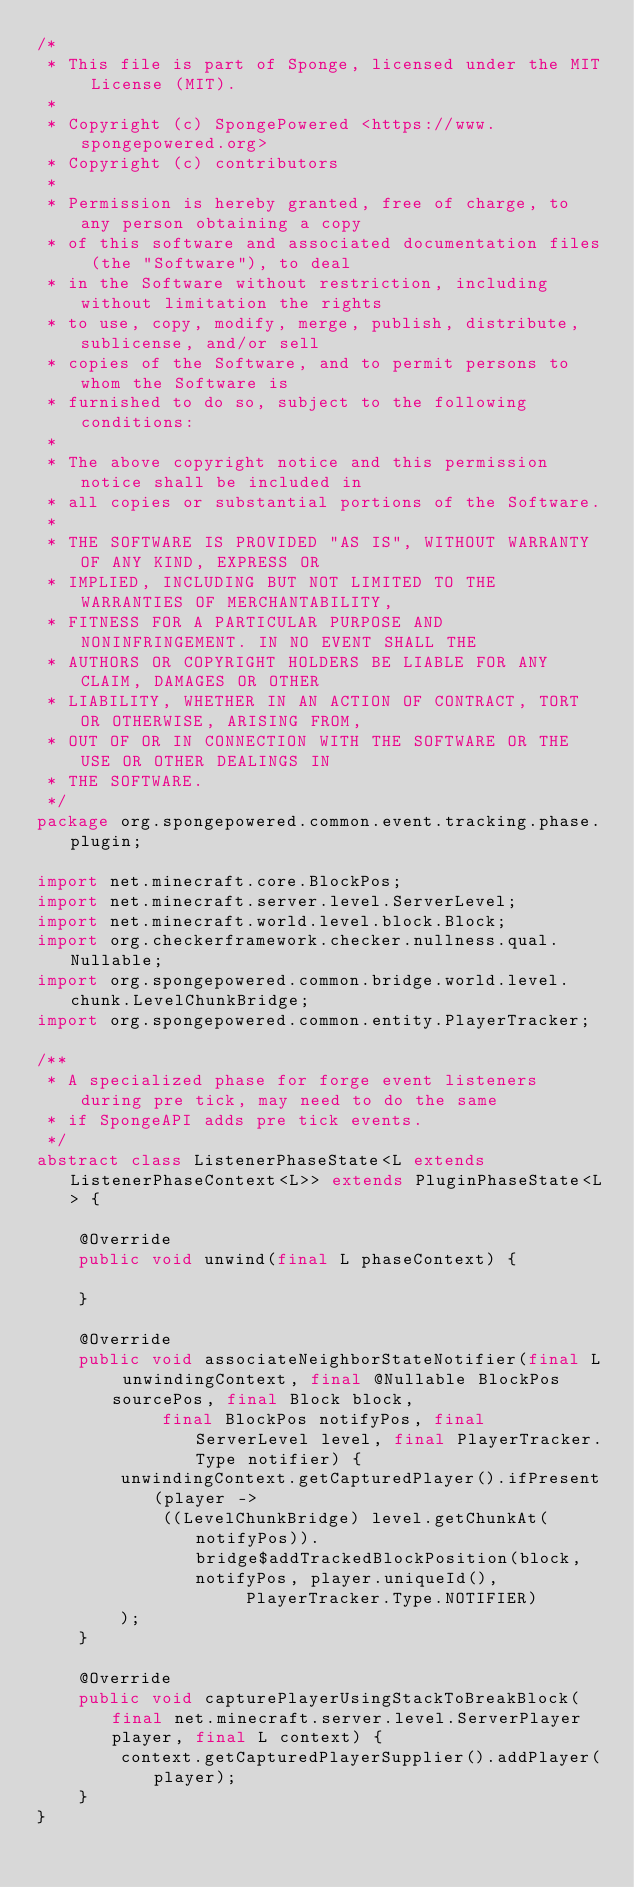Convert code to text. <code><loc_0><loc_0><loc_500><loc_500><_Java_>/*
 * This file is part of Sponge, licensed under the MIT License (MIT).
 *
 * Copyright (c) SpongePowered <https://www.spongepowered.org>
 * Copyright (c) contributors
 *
 * Permission is hereby granted, free of charge, to any person obtaining a copy
 * of this software and associated documentation files (the "Software"), to deal
 * in the Software without restriction, including without limitation the rights
 * to use, copy, modify, merge, publish, distribute, sublicense, and/or sell
 * copies of the Software, and to permit persons to whom the Software is
 * furnished to do so, subject to the following conditions:
 *
 * The above copyright notice and this permission notice shall be included in
 * all copies or substantial portions of the Software.
 *
 * THE SOFTWARE IS PROVIDED "AS IS", WITHOUT WARRANTY OF ANY KIND, EXPRESS OR
 * IMPLIED, INCLUDING BUT NOT LIMITED TO THE WARRANTIES OF MERCHANTABILITY,
 * FITNESS FOR A PARTICULAR PURPOSE AND NONINFRINGEMENT. IN NO EVENT SHALL THE
 * AUTHORS OR COPYRIGHT HOLDERS BE LIABLE FOR ANY CLAIM, DAMAGES OR OTHER
 * LIABILITY, WHETHER IN AN ACTION OF CONTRACT, TORT OR OTHERWISE, ARISING FROM,
 * OUT OF OR IN CONNECTION WITH THE SOFTWARE OR THE USE OR OTHER DEALINGS IN
 * THE SOFTWARE.
 */
package org.spongepowered.common.event.tracking.phase.plugin;

import net.minecraft.core.BlockPos;
import net.minecraft.server.level.ServerLevel;
import net.minecraft.world.level.block.Block;
import org.checkerframework.checker.nullness.qual.Nullable;
import org.spongepowered.common.bridge.world.level.chunk.LevelChunkBridge;
import org.spongepowered.common.entity.PlayerTracker;

/**
 * A specialized phase for forge event listeners during pre tick, may need to do the same
 * if SpongeAPI adds pre tick events.
 */
abstract class ListenerPhaseState<L extends ListenerPhaseContext<L>> extends PluginPhaseState<L> {

    @Override
    public void unwind(final L phaseContext) {

    }

    @Override
    public void associateNeighborStateNotifier(final L unwindingContext, final @Nullable BlockPos sourcePos, final Block block,
            final BlockPos notifyPos, final ServerLevel level, final PlayerTracker.Type notifier) {
        unwindingContext.getCapturedPlayer().ifPresent(player ->
            ((LevelChunkBridge) level.getChunkAt(notifyPos)).bridge$addTrackedBlockPosition(block, notifyPos, player.uniqueId(),
                    PlayerTracker.Type.NOTIFIER)
        );
    }

    @Override
    public void capturePlayerUsingStackToBreakBlock(final net.minecraft.server.level.ServerPlayer player, final L context) {
        context.getCapturedPlayerSupplier().addPlayer(player);
    }
}
</code> 